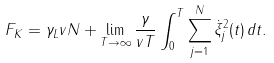<formula> <loc_0><loc_0><loc_500><loc_500>F _ { K } = \gamma _ { L } v N + \lim _ { T \to \infty } \frac { \gamma } { v T } \int _ { 0 } ^ { T } \sum _ { j = 1 } ^ { N } \dot { \xi } ^ { 2 } _ { j } ( t ) \, d t .</formula> 